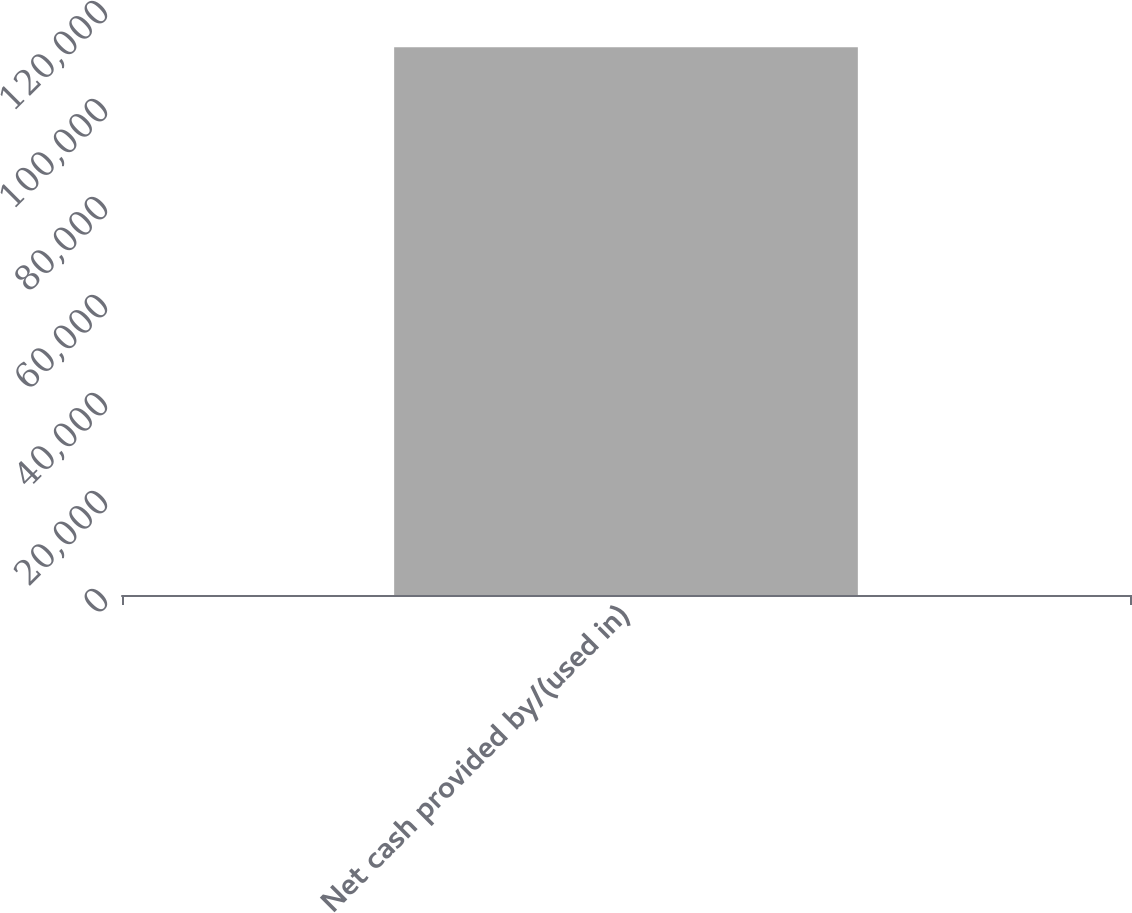Convert chart. <chart><loc_0><loc_0><loc_500><loc_500><bar_chart><fcel>Net cash provided by/(used in)<nl><fcel>111785<nl></chart> 